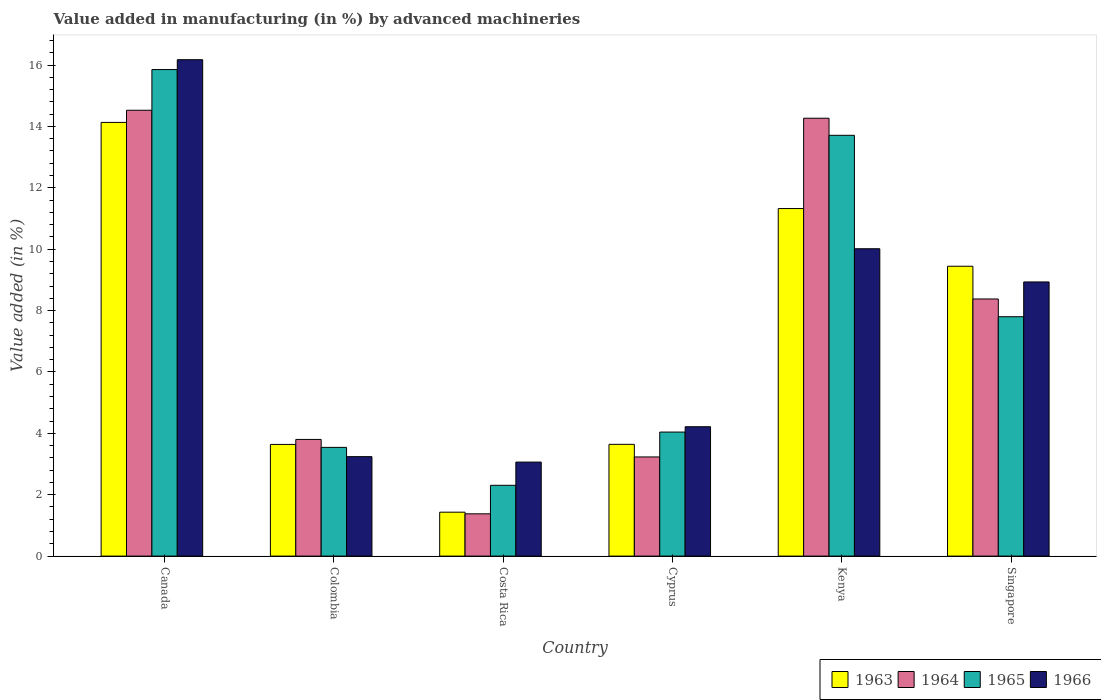How many different coloured bars are there?
Give a very brief answer. 4. Are the number of bars on each tick of the X-axis equal?
Ensure brevity in your answer.  Yes. What is the label of the 6th group of bars from the left?
Offer a terse response. Singapore. What is the percentage of value added in manufacturing by advanced machineries in 1966 in Colombia?
Your answer should be very brief. 3.24. Across all countries, what is the maximum percentage of value added in manufacturing by advanced machineries in 1964?
Make the answer very short. 14.53. Across all countries, what is the minimum percentage of value added in manufacturing by advanced machineries in 1964?
Your answer should be compact. 1.38. In which country was the percentage of value added in manufacturing by advanced machineries in 1965 maximum?
Make the answer very short. Canada. In which country was the percentage of value added in manufacturing by advanced machineries in 1963 minimum?
Your response must be concise. Costa Rica. What is the total percentage of value added in manufacturing by advanced machineries in 1966 in the graph?
Make the answer very short. 45.64. What is the difference between the percentage of value added in manufacturing by advanced machineries in 1965 in Canada and that in Costa Rica?
Your answer should be very brief. 13.55. What is the difference between the percentage of value added in manufacturing by advanced machineries in 1965 in Kenya and the percentage of value added in manufacturing by advanced machineries in 1966 in Costa Rica?
Keep it short and to the point. 10.65. What is the average percentage of value added in manufacturing by advanced machineries in 1964 per country?
Your answer should be very brief. 7.6. What is the difference between the percentage of value added in manufacturing by advanced machineries of/in 1963 and percentage of value added in manufacturing by advanced machineries of/in 1964 in Colombia?
Make the answer very short. -0.16. What is the ratio of the percentage of value added in manufacturing by advanced machineries in 1964 in Canada to that in Colombia?
Offer a terse response. 3.82. What is the difference between the highest and the second highest percentage of value added in manufacturing by advanced machineries in 1965?
Provide a short and direct response. -5.91. What is the difference between the highest and the lowest percentage of value added in manufacturing by advanced machineries in 1964?
Provide a succinct answer. 13.15. In how many countries, is the percentage of value added in manufacturing by advanced machineries in 1964 greater than the average percentage of value added in manufacturing by advanced machineries in 1964 taken over all countries?
Keep it short and to the point. 3. Is the sum of the percentage of value added in manufacturing by advanced machineries in 1963 in Kenya and Singapore greater than the maximum percentage of value added in manufacturing by advanced machineries in 1966 across all countries?
Provide a short and direct response. Yes. Is it the case that in every country, the sum of the percentage of value added in manufacturing by advanced machineries in 1964 and percentage of value added in manufacturing by advanced machineries in 1966 is greater than the sum of percentage of value added in manufacturing by advanced machineries in 1963 and percentage of value added in manufacturing by advanced machineries in 1965?
Give a very brief answer. No. How many countries are there in the graph?
Keep it short and to the point. 6. What is the difference between two consecutive major ticks on the Y-axis?
Offer a terse response. 2. Does the graph contain any zero values?
Keep it short and to the point. No. Where does the legend appear in the graph?
Your answer should be very brief. Bottom right. How many legend labels are there?
Provide a succinct answer. 4. What is the title of the graph?
Offer a terse response. Value added in manufacturing (in %) by advanced machineries. What is the label or title of the X-axis?
Offer a very short reply. Country. What is the label or title of the Y-axis?
Your answer should be very brief. Value added (in %). What is the Value added (in %) in 1963 in Canada?
Give a very brief answer. 14.13. What is the Value added (in %) in 1964 in Canada?
Offer a very short reply. 14.53. What is the Value added (in %) of 1965 in Canada?
Offer a very short reply. 15.85. What is the Value added (in %) in 1966 in Canada?
Ensure brevity in your answer.  16.17. What is the Value added (in %) of 1963 in Colombia?
Ensure brevity in your answer.  3.64. What is the Value added (in %) in 1964 in Colombia?
Your response must be concise. 3.8. What is the Value added (in %) in 1965 in Colombia?
Offer a very short reply. 3.54. What is the Value added (in %) in 1966 in Colombia?
Your answer should be compact. 3.24. What is the Value added (in %) in 1963 in Costa Rica?
Your response must be concise. 1.43. What is the Value added (in %) of 1964 in Costa Rica?
Make the answer very short. 1.38. What is the Value added (in %) in 1965 in Costa Rica?
Give a very brief answer. 2.31. What is the Value added (in %) of 1966 in Costa Rica?
Ensure brevity in your answer.  3.06. What is the Value added (in %) in 1963 in Cyprus?
Offer a very short reply. 3.64. What is the Value added (in %) of 1964 in Cyprus?
Keep it short and to the point. 3.23. What is the Value added (in %) of 1965 in Cyprus?
Offer a terse response. 4.04. What is the Value added (in %) of 1966 in Cyprus?
Your response must be concise. 4.22. What is the Value added (in %) in 1963 in Kenya?
Provide a short and direct response. 11.32. What is the Value added (in %) of 1964 in Kenya?
Ensure brevity in your answer.  14.27. What is the Value added (in %) of 1965 in Kenya?
Provide a short and direct response. 13.71. What is the Value added (in %) of 1966 in Kenya?
Your answer should be very brief. 10.01. What is the Value added (in %) in 1963 in Singapore?
Give a very brief answer. 9.44. What is the Value added (in %) of 1964 in Singapore?
Make the answer very short. 8.38. What is the Value added (in %) of 1965 in Singapore?
Offer a terse response. 7.8. What is the Value added (in %) of 1966 in Singapore?
Your answer should be very brief. 8.93. Across all countries, what is the maximum Value added (in %) in 1963?
Give a very brief answer. 14.13. Across all countries, what is the maximum Value added (in %) in 1964?
Give a very brief answer. 14.53. Across all countries, what is the maximum Value added (in %) in 1965?
Offer a very short reply. 15.85. Across all countries, what is the maximum Value added (in %) in 1966?
Your answer should be compact. 16.17. Across all countries, what is the minimum Value added (in %) in 1963?
Offer a very short reply. 1.43. Across all countries, what is the minimum Value added (in %) in 1964?
Give a very brief answer. 1.38. Across all countries, what is the minimum Value added (in %) of 1965?
Provide a short and direct response. 2.31. Across all countries, what is the minimum Value added (in %) in 1966?
Ensure brevity in your answer.  3.06. What is the total Value added (in %) in 1963 in the graph?
Make the answer very short. 43.61. What is the total Value added (in %) in 1964 in the graph?
Your answer should be compact. 45.58. What is the total Value added (in %) of 1965 in the graph?
Your response must be concise. 47.25. What is the total Value added (in %) of 1966 in the graph?
Offer a terse response. 45.64. What is the difference between the Value added (in %) in 1963 in Canada and that in Colombia?
Your answer should be compact. 10.49. What is the difference between the Value added (in %) in 1964 in Canada and that in Colombia?
Your response must be concise. 10.72. What is the difference between the Value added (in %) of 1965 in Canada and that in Colombia?
Offer a very short reply. 12.31. What is the difference between the Value added (in %) of 1966 in Canada and that in Colombia?
Your answer should be compact. 12.93. What is the difference between the Value added (in %) in 1963 in Canada and that in Costa Rica?
Offer a terse response. 12.7. What is the difference between the Value added (in %) in 1964 in Canada and that in Costa Rica?
Ensure brevity in your answer.  13.15. What is the difference between the Value added (in %) in 1965 in Canada and that in Costa Rica?
Provide a short and direct response. 13.55. What is the difference between the Value added (in %) of 1966 in Canada and that in Costa Rica?
Ensure brevity in your answer.  13.11. What is the difference between the Value added (in %) of 1963 in Canada and that in Cyprus?
Make the answer very short. 10.49. What is the difference between the Value added (in %) in 1964 in Canada and that in Cyprus?
Make the answer very short. 11.3. What is the difference between the Value added (in %) of 1965 in Canada and that in Cyprus?
Offer a very short reply. 11.81. What is the difference between the Value added (in %) of 1966 in Canada and that in Cyprus?
Your answer should be very brief. 11.96. What is the difference between the Value added (in %) of 1963 in Canada and that in Kenya?
Provide a short and direct response. 2.81. What is the difference between the Value added (in %) of 1964 in Canada and that in Kenya?
Make the answer very short. 0.26. What is the difference between the Value added (in %) in 1965 in Canada and that in Kenya?
Offer a terse response. 2.14. What is the difference between the Value added (in %) of 1966 in Canada and that in Kenya?
Ensure brevity in your answer.  6.16. What is the difference between the Value added (in %) of 1963 in Canada and that in Singapore?
Make the answer very short. 4.69. What is the difference between the Value added (in %) of 1964 in Canada and that in Singapore?
Make the answer very short. 6.15. What is the difference between the Value added (in %) of 1965 in Canada and that in Singapore?
Provide a short and direct response. 8.05. What is the difference between the Value added (in %) of 1966 in Canada and that in Singapore?
Give a very brief answer. 7.24. What is the difference between the Value added (in %) in 1963 in Colombia and that in Costa Rica?
Your answer should be very brief. 2.21. What is the difference between the Value added (in %) in 1964 in Colombia and that in Costa Rica?
Ensure brevity in your answer.  2.42. What is the difference between the Value added (in %) in 1965 in Colombia and that in Costa Rica?
Offer a terse response. 1.24. What is the difference between the Value added (in %) in 1966 in Colombia and that in Costa Rica?
Ensure brevity in your answer.  0.18. What is the difference between the Value added (in %) in 1963 in Colombia and that in Cyprus?
Your response must be concise. -0. What is the difference between the Value added (in %) in 1964 in Colombia and that in Cyprus?
Ensure brevity in your answer.  0.57. What is the difference between the Value added (in %) in 1965 in Colombia and that in Cyprus?
Your response must be concise. -0.5. What is the difference between the Value added (in %) in 1966 in Colombia and that in Cyprus?
Keep it short and to the point. -0.97. What is the difference between the Value added (in %) of 1963 in Colombia and that in Kenya?
Give a very brief answer. -7.69. What is the difference between the Value added (in %) of 1964 in Colombia and that in Kenya?
Give a very brief answer. -10.47. What is the difference between the Value added (in %) in 1965 in Colombia and that in Kenya?
Your answer should be very brief. -10.17. What is the difference between the Value added (in %) in 1966 in Colombia and that in Kenya?
Provide a short and direct response. -6.77. What is the difference between the Value added (in %) of 1963 in Colombia and that in Singapore?
Make the answer very short. -5.81. What is the difference between the Value added (in %) of 1964 in Colombia and that in Singapore?
Offer a very short reply. -4.58. What is the difference between the Value added (in %) in 1965 in Colombia and that in Singapore?
Your answer should be very brief. -4.26. What is the difference between the Value added (in %) in 1966 in Colombia and that in Singapore?
Your answer should be compact. -5.69. What is the difference between the Value added (in %) of 1963 in Costa Rica and that in Cyprus?
Your answer should be very brief. -2.21. What is the difference between the Value added (in %) of 1964 in Costa Rica and that in Cyprus?
Provide a succinct answer. -1.85. What is the difference between the Value added (in %) in 1965 in Costa Rica and that in Cyprus?
Ensure brevity in your answer.  -1.73. What is the difference between the Value added (in %) of 1966 in Costa Rica and that in Cyprus?
Offer a very short reply. -1.15. What is the difference between the Value added (in %) of 1963 in Costa Rica and that in Kenya?
Offer a terse response. -9.89. What is the difference between the Value added (in %) of 1964 in Costa Rica and that in Kenya?
Make the answer very short. -12.89. What is the difference between the Value added (in %) in 1965 in Costa Rica and that in Kenya?
Offer a very short reply. -11.4. What is the difference between the Value added (in %) in 1966 in Costa Rica and that in Kenya?
Provide a short and direct response. -6.95. What is the difference between the Value added (in %) in 1963 in Costa Rica and that in Singapore?
Offer a very short reply. -8.01. What is the difference between the Value added (in %) in 1964 in Costa Rica and that in Singapore?
Your answer should be compact. -7. What is the difference between the Value added (in %) of 1965 in Costa Rica and that in Singapore?
Ensure brevity in your answer.  -5.49. What is the difference between the Value added (in %) of 1966 in Costa Rica and that in Singapore?
Offer a terse response. -5.87. What is the difference between the Value added (in %) in 1963 in Cyprus and that in Kenya?
Provide a succinct answer. -7.68. What is the difference between the Value added (in %) in 1964 in Cyprus and that in Kenya?
Make the answer very short. -11.04. What is the difference between the Value added (in %) in 1965 in Cyprus and that in Kenya?
Offer a very short reply. -9.67. What is the difference between the Value added (in %) of 1966 in Cyprus and that in Kenya?
Keep it short and to the point. -5.8. What is the difference between the Value added (in %) of 1963 in Cyprus and that in Singapore?
Make the answer very short. -5.8. What is the difference between the Value added (in %) of 1964 in Cyprus and that in Singapore?
Your answer should be very brief. -5.15. What is the difference between the Value added (in %) in 1965 in Cyprus and that in Singapore?
Offer a terse response. -3.76. What is the difference between the Value added (in %) in 1966 in Cyprus and that in Singapore?
Provide a succinct answer. -4.72. What is the difference between the Value added (in %) of 1963 in Kenya and that in Singapore?
Your answer should be compact. 1.88. What is the difference between the Value added (in %) in 1964 in Kenya and that in Singapore?
Offer a terse response. 5.89. What is the difference between the Value added (in %) of 1965 in Kenya and that in Singapore?
Ensure brevity in your answer.  5.91. What is the difference between the Value added (in %) in 1966 in Kenya and that in Singapore?
Your response must be concise. 1.08. What is the difference between the Value added (in %) of 1963 in Canada and the Value added (in %) of 1964 in Colombia?
Make the answer very short. 10.33. What is the difference between the Value added (in %) of 1963 in Canada and the Value added (in %) of 1965 in Colombia?
Your answer should be compact. 10.59. What is the difference between the Value added (in %) of 1963 in Canada and the Value added (in %) of 1966 in Colombia?
Give a very brief answer. 10.89. What is the difference between the Value added (in %) in 1964 in Canada and the Value added (in %) in 1965 in Colombia?
Offer a very short reply. 10.98. What is the difference between the Value added (in %) of 1964 in Canada and the Value added (in %) of 1966 in Colombia?
Ensure brevity in your answer.  11.29. What is the difference between the Value added (in %) of 1965 in Canada and the Value added (in %) of 1966 in Colombia?
Your response must be concise. 12.61. What is the difference between the Value added (in %) of 1963 in Canada and the Value added (in %) of 1964 in Costa Rica?
Offer a terse response. 12.75. What is the difference between the Value added (in %) of 1963 in Canada and the Value added (in %) of 1965 in Costa Rica?
Your answer should be compact. 11.82. What is the difference between the Value added (in %) of 1963 in Canada and the Value added (in %) of 1966 in Costa Rica?
Make the answer very short. 11.07. What is the difference between the Value added (in %) in 1964 in Canada and the Value added (in %) in 1965 in Costa Rica?
Provide a succinct answer. 12.22. What is the difference between the Value added (in %) of 1964 in Canada and the Value added (in %) of 1966 in Costa Rica?
Provide a succinct answer. 11.46. What is the difference between the Value added (in %) in 1965 in Canada and the Value added (in %) in 1966 in Costa Rica?
Make the answer very short. 12.79. What is the difference between the Value added (in %) in 1963 in Canada and the Value added (in %) in 1964 in Cyprus?
Offer a very short reply. 10.9. What is the difference between the Value added (in %) of 1963 in Canada and the Value added (in %) of 1965 in Cyprus?
Your answer should be very brief. 10.09. What is the difference between the Value added (in %) of 1963 in Canada and the Value added (in %) of 1966 in Cyprus?
Provide a succinct answer. 9.92. What is the difference between the Value added (in %) of 1964 in Canada and the Value added (in %) of 1965 in Cyprus?
Your answer should be very brief. 10.49. What is the difference between the Value added (in %) in 1964 in Canada and the Value added (in %) in 1966 in Cyprus?
Your response must be concise. 10.31. What is the difference between the Value added (in %) in 1965 in Canada and the Value added (in %) in 1966 in Cyprus?
Your response must be concise. 11.64. What is the difference between the Value added (in %) in 1963 in Canada and the Value added (in %) in 1964 in Kenya?
Make the answer very short. -0.14. What is the difference between the Value added (in %) in 1963 in Canada and the Value added (in %) in 1965 in Kenya?
Your answer should be very brief. 0.42. What is the difference between the Value added (in %) in 1963 in Canada and the Value added (in %) in 1966 in Kenya?
Ensure brevity in your answer.  4.12. What is the difference between the Value added (in %) of 1964 in Canada and the Value added (in %) of 1965 in Kenya?
Make the answer very short. 0.82. What is the difference between the Value added (in %) in 1964 in Canada and the Value added (in %) in 1966 in Kenya?
Make the answer very short. 4.51. What is the difference between the Value added (in %) of 1965 in Canada and the Value added (in %) of 1966 in Kenya?
Offer a very short reply. 5.84. What is the difference between the Value added (in %) of 1963 in Canada and the Value added (in %) of 1964 in Singapore?
Keep it short and to the point. 5.75. What is the difference between the Value added (in %) of 1963 in Canada and the Value added (in %) of 1965 in Singapore?
Offer a very short reply. 6.33. What is the difference between the Value added (in %) in 1963 in Canada and the Value added (in %) in 1966 in Singapore?
Offer a very short reply. 5.2. What is the difference between the Value added (in %) in 1964 in Canada and the Value added (in %) in 1965 in Singapore?
Ensure brevity in your answer.  6.73. What is the difference between the Value added (in %) in 1964 in Canada and the Value added (in %) in 1966 in Singapore?
Ensure brevity in your answer.  5.59. What is the difference between the Value added (in %) of 1965 in Canada and the Value added (in %) of 1966 in Singapore?
Offer a terse response. 6.92. What is the difference between the Value added (in %) of 1963 in Colombia and the Value added (in %) of 1964 in Costa Rica?
Give a very brief answer. 2.26. What is the difference between the Value added (in %) in 1963 in Colombia and the Value added (in %) in 1965 in Costa Rica?
Offer a terse response. 1.33. What is the difference between the Value added (in %) of 1963 in Colombia and the Value added (in %) of 1966 in Costa Rica?
Your answer should be very brief. 0.57. What is the difference between the Value added (in %) in 1964 in Colombia and the Value added (in %) in 1965 in Costa Rica?
Ensure brevity in your answer.  1.49. What is the difference between the Value added (in %) of 1964 in Colombia and the Value added (in %) of 1966 in Costa Rica?
Your answer should be compact. 0.74. What is the difference between the Value added (in %) in 1965 in Colombia and the Value added (in %) in 1966 in Costa Rica?
Ensure brevity in your answer.  0.48. What is the difference between the Value added (in %) in 1963 in Colombia and the Value added (in %) in 1964 in Cyprus?
Make the answer very short. 0.41. What is the difference between the Value added (in %) of 1963 in Colombia and the Value added (in %) of 1965 in Cyprus?
Keep it short and to the point. -0.4. What is the difference between the Value added (in %) of 1963 in Colombia and the Value added (in %) of 1966 in Cyprus?
Offer a very short reply. -0.58. What is the difference between the Value added (in %) of 1964 in Colombia and the Value added (in %) of 1965 in Cyprus?
Provide a short and direct response. -0.24. What is the difference between the Value added (in %) in 1964 in Colombia and the Value added (in %) in 1966 in Cyprus?
Your answer should be very brief. -0.41. What is the difference between the Value added (in %) of 1965 in Colombia and the Value added (in %) of 1966 in Cyprus?
Give a very brief answer. -0.67. What is the difference between the Value added (in %) of 1963 in Colombia and the Value added (in %) of 1964 in Kenya?
Offer a very short reply. -10.63. What is the difference between the Value added (in %) in 1963 in Colombia and the Value added (in %) in 1965 in Kenya?
Offer a terse response. -10.07. What is the difference between the Value added (in %) in 1963 in Colombia and the Value added (in %) in 1966 in Kenya?
Offer a very short reply. -6.38. What is the difference between the Value added (in %) of 1964 in Colombia and the Value added (in %) of 1965 in Kenya?
Make the answer very short. -9.91. What is the difference between the Value added (in %) in 1964 in Colombia and the Value added (in %) in 1966 in Kenya?
Your answer should be compact. -6.21. What is the difference between the Value added (in %) in 1965 in Colombia and the Value added (in %) in 1966 in Kenya?
Offer a terse response. -6.47. What is the difference between the Value added (in %) of 1963 in Colombia and the Value added (in %) of 1964 in Singapore?
Provide a succinct answer. -4.74. What is the difference between the Value added (in %) in 1963 in Colombia and the Value added (in %) in 1965 in Singapore?
Ensure brevity in your answer.  -4.16. What is the difference between the Value added (in %) in 1963 in Colombia and the Value added (in %) in 1966 in Singapore?
Your response must be concise. -5.29. What is the difference between the Value added (in %) of 1964 in Colombia and the Value added (in %) of 1965 in Singapore?
Your answer should be very brief. -4. What is the difference between the Value added (in %) of 1964 in Colombia and the Value added (in %) of 1966 in Singapore?
Provide a short and direct response. -5.13. What is the difference between the Value added (in %) in 1965 in Colombia and the Value added (in %) in 1966 in Singapore?
Provide a short and direct response. -5.39. What is the difference between the Value added (in %) of 1963 in Costa Rica and the Value added (in %) of 1964 in Cyprus?
Offer a very short reply. -1.8. What is the difference between the Value added (in %) in 1963 in Costa Rica and the Value added (in %) in 1965 in Cyprus?
Your response must be concise. -2.61. What is the difference between the Value added (in %) in 1963 in Costa Rica and the Value added (in %) in 1966 in Cyprus?
Offer a terse response. -2.78. What is the difference between the Value added (in %) of 1964 in Costa Rica and the Value added (in %) of 1965 in Cyprus?
Ensure brevity in your answer.  -2.66. What is the difference between the Value added (in %) of 1964 in Costa Rica and the Value added (in %) of 1966 in Cyprus?
Your answer should be compact. -2.84. What is the difference between the Value added (in %) in 1965 in Costa Rica and the Value added (in %) in 1966 in Cyprus?
Offer a terse response. -1.91. What is the difference between the Value added (in %) of 1963 in Costa Rica and the Value added (in %) of 1964 in Kenya?
Keep it short and to the point. -12.84. What is the difference between the Value added (in %) of 1963 in Costa Rica and the Value added (in %) of 1965 in Kenya?
Offer a very short reply. -12.28. What is the difference between the Value added (in %) of 1963 in Costa Rica and the Value added (in %) of 1966 in Kenya?
Ensure brevity in your answer.  -8.58. What is the difference between the Value added (in %) of 1964 in Costa Rica and the Value added (in %) of 1965 in Kenya?
Ensure brevity in your answer.  -12.33. What is the difference between the Value added (in %) of 1964 in Costa Rica and the Value added (in %) of 1966 in Kenya?
Offer a terse response. -8.64. What is the difference between the Value added (in %) in 1965 in Costa Rica and the Value added (in %) in 1966 in Kenya?
Give a very brief answer. -7.71. What is the difference between the Value added (in %) of 1963 in Costa Rica and the Value added (in %) of 1964 in Singapore?
Your answer should be very brief. -6.95. What is the difference between the Value added (in %) of 1963 in Costa Rica and the Value added (in %) of 1965 in Singapore?
Keep it short and to the point. -6.37. What is the difference between the Value added (in %) in 1963 in Costa Rica and the Value added (in %) in 1966 in Singapore?
Offer a very short reply. -7.5. What is the difference between the Value added (in %) of 1964 in Costa Rica and the Value added (in %) of 1965 in Singapore?
Give a very brief answer. -6.42. What is the difference between the Value added (in %) of 1964 in Costa Rica and the Value added (in %) of 1966 in Singapore?
Your answer should be very brief. -7.55. What is the difference between the Value added (in %) of 1965 in Costa Rica and the Value added (in %) of 1966 in Singapore?
Ensure brevity in your answer.  -6.63. What is the difference between the Value added (in %) of 1963 in Cyprus and the Value added (in %) of 1964 in Kenya?
Keep it short and to the point. -10.63. What is the difference between the Value added (in %) in 1963 in Cyprus and the Value added (in %) in 1965 in Kenya?
Your response must be concise. -10.07. What is the difference between the Value added (in %) in 1963 in Cyprus and the Value added (in %) in 1966 in Kenya?
Provide a short and direct response. -6.37. What is the difference between the Value added (in %) in 1964 in Cyprus and the Value added (in %) in 1965 in Kenya?
Provide a succinct answer. -10.48. What is the difference between the Value added (in %) of 1964 in Cyprus and the Value added (in %) of 1966 in Kenya?
Your response must be concise. -6.78. What is the difference between the Value added (in %) in 1965 in Cyprus and the Value added (in %) in 1966 in Kenya?
Offer a very short reply. -5.97. What is the difference between the Value added (in %) in 1963 in Cyprus and the Value added (in %) in 1964 in Singapore?
Make the answer very short. -4.74. What is the difference between the Value added (in %) in 1963 in Cyprus and the Value added (in %) in 1965 in Singapore?
Ensure brevity in your answer.  -4.16. What is the difference between the Value added (in %) of 1963 in Cyprus and the Value added (in %) of 1966 in Singapore?
Keep it short and to the point. -5.29. What is the difference between the Value added (in %) in 1964 in Cyprus and the Value added (in %) in 1965 in Singapore?
Give a very brief answer. -4.57. What is the difference between the Value added (in %) in 1964 in Cyprus and the Value added (in %) in 1966 in Singapore?
Offer a terse response. -5.7. What is the difference between the Value added (in %) in 1965 in Cyprus and the Value added (in %) in 1966 in Singapore?
Your answer should be very brief. -4.89. What is the difference between the Value added (in %) of 1963 in Kenya and the Value added (in %) of 1964 in Singapore?
Your response must be concise. 2.95. What is the difference between the Value added (in %) of 1963 in Kenya and the Value added (in %) of 1965 in Singapore?
Provide a succinct answer. 3.52. What is the difference between the Value added (in %) of 1963 in Kenya and the Value added (in %) of 1966 in Singapore?
Keep it short and to the point. 2.39. What is the difference between the Value added (in %) in 1964 in Kenya and the Value added (in %) in 1965 in Singapore?
Provide a succinct answer. 6.47. What is the difference between the Value added (in %) in 1964 in Kenya and the Value added (in %) in 1966 in Singapore?
Keep it short and to the point. 5.33. What is the difference between the Value added (in %) of 1965 in Kenya and the Value added (in %) of 1966 in Singapore?
Provide a short and direct response. 4.78. What is the average Value added (in %) of 1963 per country?
Provide a short and direct response. 7.27. What is the average Value added (in %) of 1964 per country?
Your answer should be compact. 7.6. What is the average Value added (in %) in 1965 per country?
Make the answer very short. 7.88. What is the average Value added (in %) of 1966 per country?
Offer a very short reply. 7.61. What is the difference between the Value added (in %) of 1963 and Value added (in %) of 1964 in Canada?
Your answer should be very brief. -0.4. What is the difference between the Value added (in %) in 1963 and Value added (in %) in 1965 in Canada?
Your answer should be very brief. -1.72. What is the difference between the Value added (in %) in 1963 and Value added (in %) in 1966 in Canada?
Give a very brief answer. -2.04. What is the difference between the Value added (in %) of 1964 and Value added (in %) of 1965 in Canada?
Ensure brevity in your answer.  -1.33. What is the difference between the Value added (in %) in 1964 and Value added (in %) in 1966 in Canada?
Provide a short and direct response. -1.65. What is the difference between the Value added (in %) of 1965 and Value added (in %) of 1966 in Canada?
Provide a short and direct response. -0.32. What is the difference between the Value added (in %) in 1963 and Value added (in %) in 1964 in Colombia?
Provide a short and direct response. -0.16. What is the difference between the Value added (in %) of 1963 and Value added (in %) of 1965 in Colombia?
Your answer should be very brief. 0.1. What is the difference between the Value added (in %) of 1963 and Value added (in %) of 1966 in Colombia?
Provide a succinct answer. 0.4. What is the difference between the Value added (in %) of 1964 and Value added (in %) of 1965 in Colombia?
Provide a short and direct response. 0.26. What is the difference between the Value added (in %) of 1964 and Value added (in %) of 1966 in Colombia?
Your response must be concise. 0.56. What is the difference between the Value added (in %) of 1965 and Value added (in %) of 1966 in Colombia?
Your response must be concise. 0.3. What is the difference between the Value added (in %) in 1963 and Value added (in %) in 1964 in Costa Rica?
Offer a terse response. 0.05. What is the difference between the Value added (in %) of 1963 and Value added (in %) of 1965 in Costa Rica?
Keep it short and to the point. -0.88. What is the difference between the Value added (in %) in 1963 and Value added (in %) in 1966 in Costa Rica?
Your answer should be very brief. -1.63. What is the difference between the Value added (in %) in 1964 and Value added (in %) in 1965 in Costa Rica?
Your answer should be very brief. -0.93. What is the difference between the Value added (in %) of 1964 and Value added (in %) of 1966 in Costa Rica?
Make the answer very short. -1.69. What is the difference between the Value added (in %) in 1965 and Value added (in %) in 1966 in Costa Rica?
Provide a short and direct response. -0.76. What is the difference between the Value added (in %) of 1963 and Value added (in %) of 1964 in Cyprus?
Provide a succinct answer. 0.41. What is the difference between the Value added (in %) in 1963 and Value added (in %) in 1965 in Cyprus?
Provide a short and direct response. -0.4. What is the difference between the Value added (in %) in 1963 and Value added (in %) in 1966 in Cyprus?
Ensure brevity in your answer.  -0.57. What is the difference between the Value added (in %) in 1964 and Value added (in %) in 1965 in Cyprus?
Provide a short and direct response. -0.81. What is the difference between the Value added (in %) in 1964 and Value added (in %) in 1966 in Cyprus?
Your answer should be very brief. -0.98. What is the difference between the Value added (in %) in 1965 and Value added (in %) in 1966 in Cyprus?
Provide a succinct answer. -0.17. What is the difference between the Value added (in %) in 1963 and Value added (in %) in 1964 in Kenya?
Make the answer very short. -2.94. What is the difference between the Value added (in %) of 1963 and Value added (in %) of 1965 in Kenya?
Offer a very short reply. -2.39. What is the difference between the Value added (in %) of 1963 and Value added (in %) of 1966 in Kenya?
Ensure brevity in your answer.  1.31. What is the difference between the Value added (in %) of 1964 and Value added (in %) of 1965 in Kenya?
Your answer should be compact. 0.56. What is the difference between the Value added (in %) in 1964 and Value added (in %) in 1966 in Kenya?
Your answer should be compact. 4.25. What is the difference between the Value added (in %) of 1965 and Value added (in %) of 1966 in Kenya?
Give a very brief answer. 3.7. What is the difference between the Value added (in %) of 1963 and Value added (in %) of 1964 in Singapore?
Ensure brevity in your answer.  1.07. What is the difference between the Value added (in %) of 1963 and Value added (in %) of 1965 in Singapore?
Offer a terse response. 1.64. What is the difference between the Value added (in %) of 1963 and Value added (in %) of 1966 in Singapore?
Your response must be concise. 0.51. What is the difference between the Value added (in %) in 1964 and Value added (in %) in 1965 in Singapore?
Make the answer very short. 0.58. What is the difference between the Value added (in %) in 1964 and Value added (in %) in 1966 in Singapore?
Your response must be concise. -0.55. What is the difference between the Value added (in %) of 1965 and Value added (in %) of 1966 in Singapore?
Your answer should be compact. -1.13. What is the ratio of the Value added (in %) in 1963 in Canada to that in Colombia?
Ensure brevity in your answer.  3.88. What is the ratio of the Value added (in %) in 1964 in Canada to that in Colombia?
Give a very brief answer. 3.82. What is the ratio of the Value added (in %) of 1965 in Canada to that in Colombia?
Give a very brief answer. 4.48. What is the ratio of the Value added (in %) in 1966 in Canada to that in Colombia?
Offer a very short reply. 4.99. What is the ratio of the Value added (in %) in 1963 in Canada to that in Costa Rica?
Keep it short and to the point. 9.87. What is the ratio of the Value added (in %) in 1964 in Canada to that in Costa Rica?
Ensure brevity in your answer.  10.54. What is the ratio of the Value added (in %) of 1965 in Canada to that in Costa Rica?
Make the answer very short. 6.87. What is the ratio of the Value added (in %) in 1966 in Canada to that in Costa Rica?
Ensure brevity in your answer.  5.28. What is the ratio of the Value added (in %) of 1963 in Canada to that in Cyprus?
Provide a succinct answer. 3.88. What is the ratio of the Value added (in %) in 1964 in Canada to that in Cyprus?
Provide a succinct answer. 4.5. What is the ratio of the Value added (in %) of 1965 in Canada to that in Cyprus?
Give a very brief answer. 3.92. What is the ratio of the Value added (in %) of 1966 in Canada to that in Cyprus?
Your answer should be very brief. 3.84. What is the ratio of the Value added (in %) in 1963 in Canada to that in Kenya?
Offer a terse response. 1.25. What is the ratio of the Value added (in %) in 1964 in Canada to that in Kenya?
Provide a succinct answer. 1.02. What is the ratio of the Value added (in %) in 1965 in Canada to that in Kenya?
Provide a succinct answer. 1.16. What is the ratio of the Value added (in %) of 1966 in Canada to that in Kenya?
Ensure brevity in your answer.  1.62. What is the ratio of the Value added (in %) in 1963 in Canada to that in Singapore?
Give a very brief answer. 1.5. What is the ratio of the Value added (in %) in 1964 in Canada to that in Singapore?
Give a very brief answer. 1.73. What is the ratio of the Value added (in %) in 1965 in Canada to that in Singapore?
Offer a terse response. 2.03. What is the ratio of the Value added (in %) of 1966 in Canada to that in Singapore?
Keep it short and to the point. 1.81. What is the ratio of the Value added (in %) in 1963 in Colombia to that in Costa Rica?
Your answer should be very brief. 2.54. What is the ratio of the Value added (in %) in 1964 in Colombia to that in Costa Rica?
Your response must be concise. 2.76. What is the ratio of the Value added (in %) of 1965 in Colombia to that in Costa Rica?
Keep it short and to the point. 1.54. What is the ratio of the Value added (in %) of 1966 in Colombia to that in Costa Rica?
Make the answer very short. 1.06. What is the ratio of the Value added (in %) of 1964 in Colombia to that in Cyprus?
Keep it short and to the point. 1.18. What is the ratio of the Value added (in %) of 1965 in Colombia to that in Cyprus?
Offer a terse response. 0.88. What is the ratio of the Value added (in %) of 1966 in Colombia to that in Cyprus?
Offer a terse response. 0.77. What is the ratio of the Value added (in %) in 1963 in Colombia to that in Kenya?
Your answer should be compact. 0.32. What is the ratio of the Value added (in %) in 1964 in Colombia to that in Kenya?
Make the answer very short. 0.27. What is the ratio of the Value added (in %) in 1965 in Colombia to that in Kenya?
Provide a succinct answer. 0.26. What is the ratio of the Value added (in %) in 1966 in Colombia to that in Kenya?
Make the answer very short. 0.32. What is the ratio of the Value added (in %) of 1963 in Colombia to that in Singapore?
Offer a terse response. 0.39. What is the ratio of the Value added (in %) in 1964 in Colombia to that in Singapore?
Offer a very short reply. 0.45. What is the ratio of the Value added (in %) in 1965 in Colombia to that in Singapore?
Offer a very short reply. 0.45. What is the ratio of the Value added (in %) of 1966 in Colombia to that in Singapore?
Give a very brief answer. 0.36. What is the ratio of the Value added (in %) of 1963 in Costa Rica to that in Cyprus?
Provide a short and direct response. 0.39. What is the ratio of the Value added (in %) of 1964 in Costa Rica to that in Cyprus?
Your answer should be compact. 0.43. What is the ratio of the Value added (in %) of 1965 in Costa Rica to that in Cyprus?
Your response must be concise. 0.57. What is the ratio of the Value added (in %) of 1966 in Costa Rica to that in Cyprus?
Give a very brief answer. 0.73. What is the ratio of the Value added (in %) of 1963 in Costa Rica to that in Kenya?
Offer a terse response. 0.13. What is the ratio of the Value added (in %) in 1964 in Costa Rica to that in Kenya?
Provide a short and direct response. 0.1. What is the ratio of the Value added (in %) of 1965 in Costa Rica to that in Kenya?
Keep it short and to the point. 0.17. What is the ratio of the Value added (in %) of 1966 in Costa Rica to that in Kenya?
Your answer should be compact. 0.31. What is the ratio of the Value added (in %) in 1963 in Costa Rica to that in Singapore?
Keep it short and to the point. 0.15. What is the ratio of the Value added (in %) of 1964 in Costa Rica to that in Singapore?
Make the answer very short. 0.16. What is the ratio of the Value added (in %) in 1965 in Costa Rica to that in Singapore?
Your answer should be very brief. 0.3. What is the ratio of the Value added (in %) of 1966 in Costa Rica to that in Singapore?
Keep it short and to the point. 0.34. What is the ratio of the Value added (in %) in 1963 in Cyprus to that in Kenya?
Provide a succinct answer. 0.32. What is the ratio of the Value added (in %) of 1964 in Cyprus to that in Kenya?
Provide a succinct answer. 0.23. What is the ratio of the Value added (in %) in 1965 in Cyprus to that in Kenya?
Provide a short and direct response. 0.29. What is the ratio of the Value added (in %) in 1966 in Cyprus to that in Kenya?
Your answer should be very brief. 0.42. What is the ratio of the Value added (in %) in 1963 in Cyprus to that in Singapore?
Keep it short and to the point. 0.39. What is the ratio of the Value added (in %) in 1964 in Cyprus to that in Singapore?
Make the answer very short. 0.39. What is the ratio of the Value added (in %) of 1965 in Cyprus to that in Singapore?
Ensure brevity in your answer.  0.52. What is the ratio of the Value added (in %) in 1966 in Cyprus to that in Singapore?
Keep it short and to the point. 0.47. What is the ratio of the Value added (in %) in 1963 in Kenya to that in Singapore?
Offer a terse response. 1.2. What is the ratio of the Value added (in %) in 1964 in Kenya to that in Singapore?
Provide a short and direct response. 1.7. What is the ratio of the Value added (in %) in 1965 in Kenya to that in Singapore?
Offer a very short reply. 1.76. What is the ratio of the Value added (in %) of 1966 in Kenya to that in Singapore?
Offer a very short reply. 1.12. What is the difference between the highest and the second highest Value added (in %) of 1963?
Keep it short and to the point. 2.81. What is the difference between the highest and the second highest Value added (in %) in 1964?
Give a very brief answer. 0.26. What is the difference between the highest and the second highest Value added (in %) in 1965?
Give a very brief answer. 2.14. What is the difference between the highest and the second highest Value added (in %) in 1966?
Your answer should be very brief. 6.16. What is the difference between the highest and the lowest Value added (in %) of 1963?
Give a very brief answer. 12.7. What is the difference between the highest and the lowest Value added (in %) in 1964?
Provide a succinct answer. 13.15. What is the difference between the highest and the lowest Value added (in %) of 1965?
Make the answer very short. 13.55. What is the difference between the highest and the lowest Value added (in %) in 1966?
Your answer should be very brief. 13.11. 